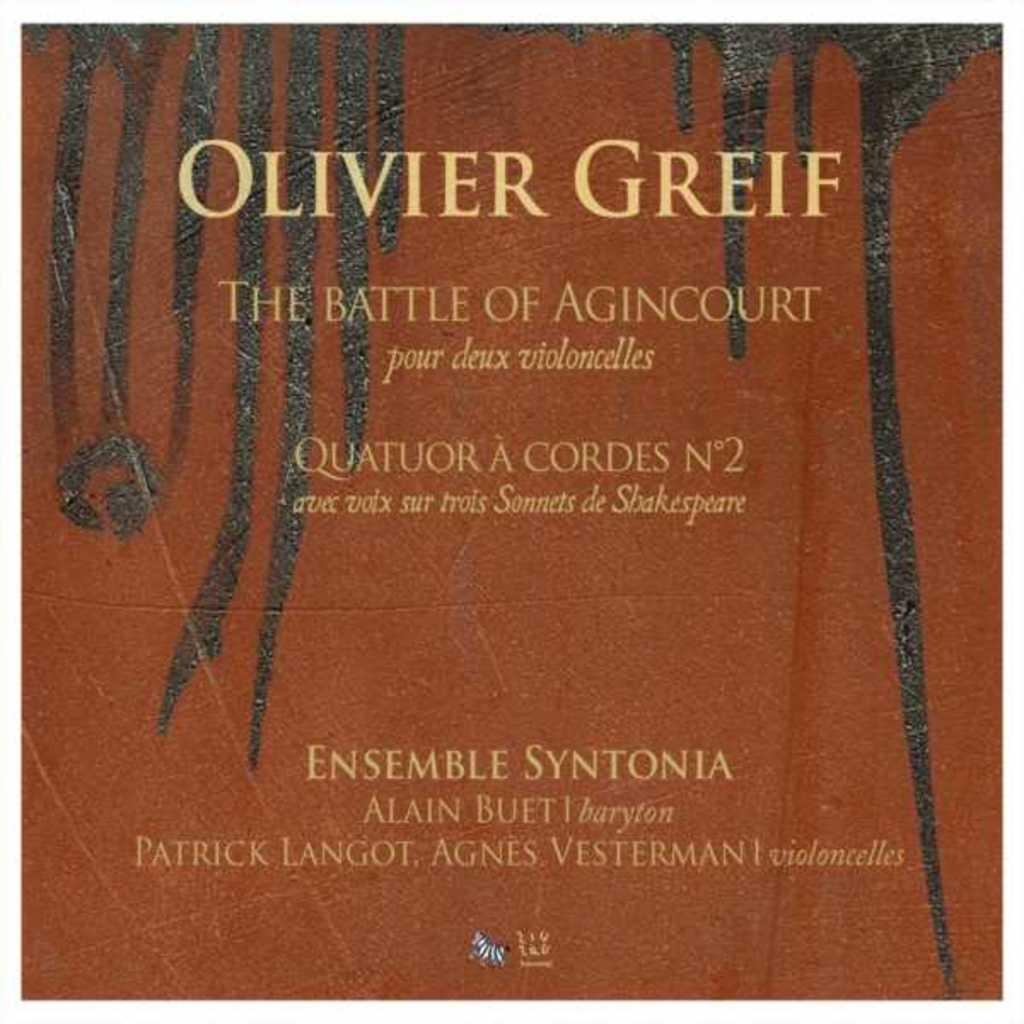<image>
Render a clear and concise summary of the photo. The Battle of Agincourt by Olivier Greif is a musical work. 